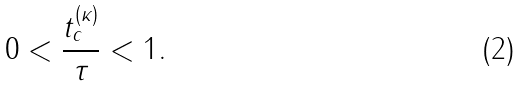<formula> <loc_0><loc_0><loc_500><loc_500>0 < \frac { t ^ { ( \kappa ) } _ { c } } { \tau } < 1 .</formula> 